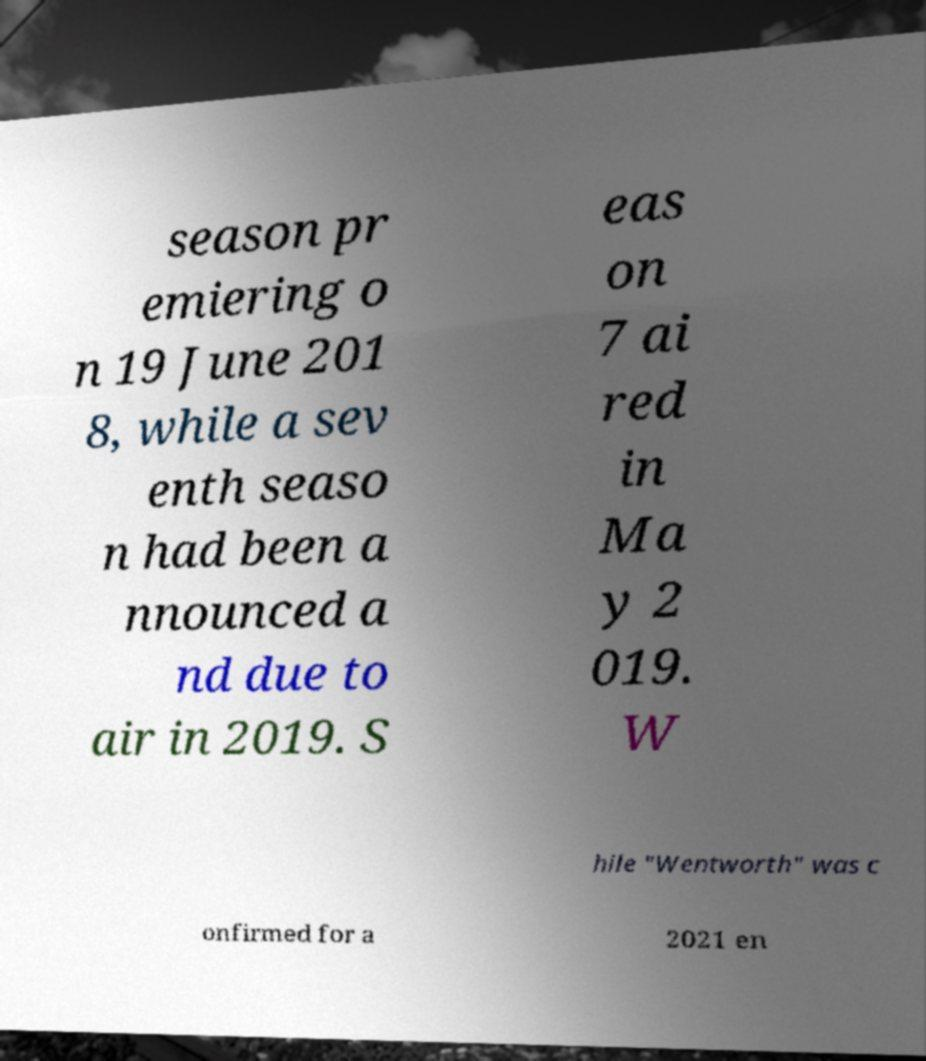Can you accurately transcribe the text from the provided image for me? season pr emiering o n 19 June 201 8, while a sev enth seaso n had been a nnounced a nd due to air in 2019. S eas on 7 ai red in Ma y 2 019. W hile "Wentworth" was c onfirmed for a 2021 en 